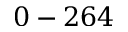Convert formula to latex. <formula><loc_0><loc_0><loc_500><loc_500>0 - 2 6 4</formula> 